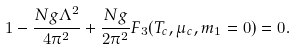Convert formula to latex. <formula><loc_0><loc_0><loc_500><loc_500>1 - \frac { N g \Lambda ^ { 2 } } { 4 \pi ^ { 2 } } + \frac { N g } { 2 \pi ^ { 2 } } F _ { 3 } ( T _ { c } , \mu _ { c } , m _ { 1 } = 0 ) = 0 .</formula> 